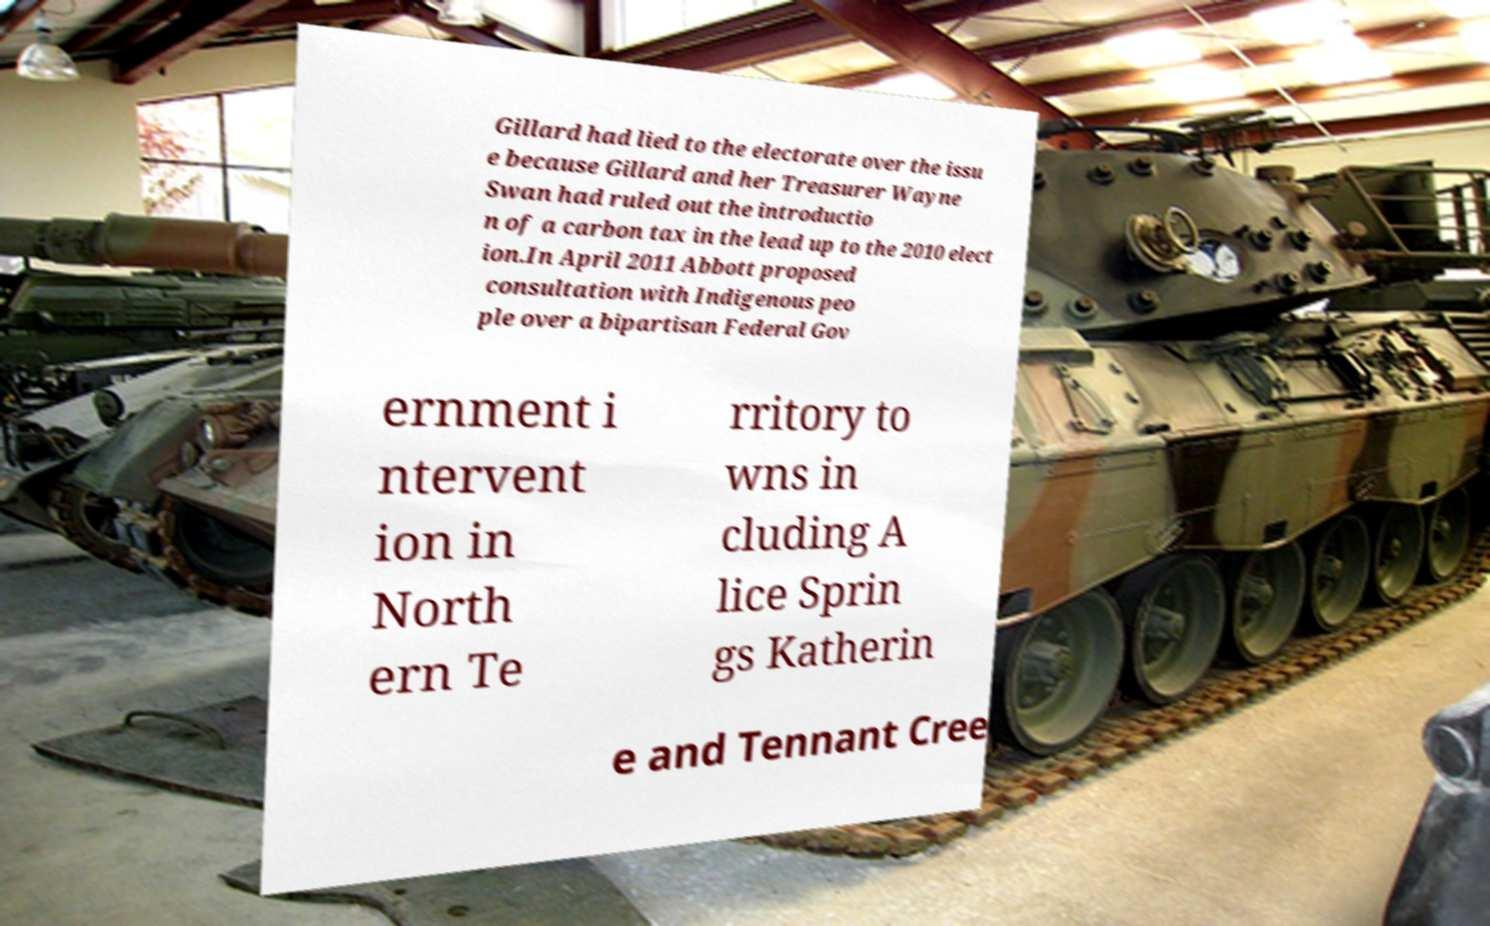Could you extract and type out the text from this image? Gillard had lied to the electorate over the issu e because Gillard and her Treasurer Wayne Swan had ruled out the introductio n of a carbon tax in the lead up to the 2010 elect ion.In April 2011 Abbott proposed consultation with Indigenous peo ple over a bipartisan Federal Gov ernment i ntervent ion in North ern Te rritory to wns in cluding A lice Sprin gs Katherin e and Tennant Cree 